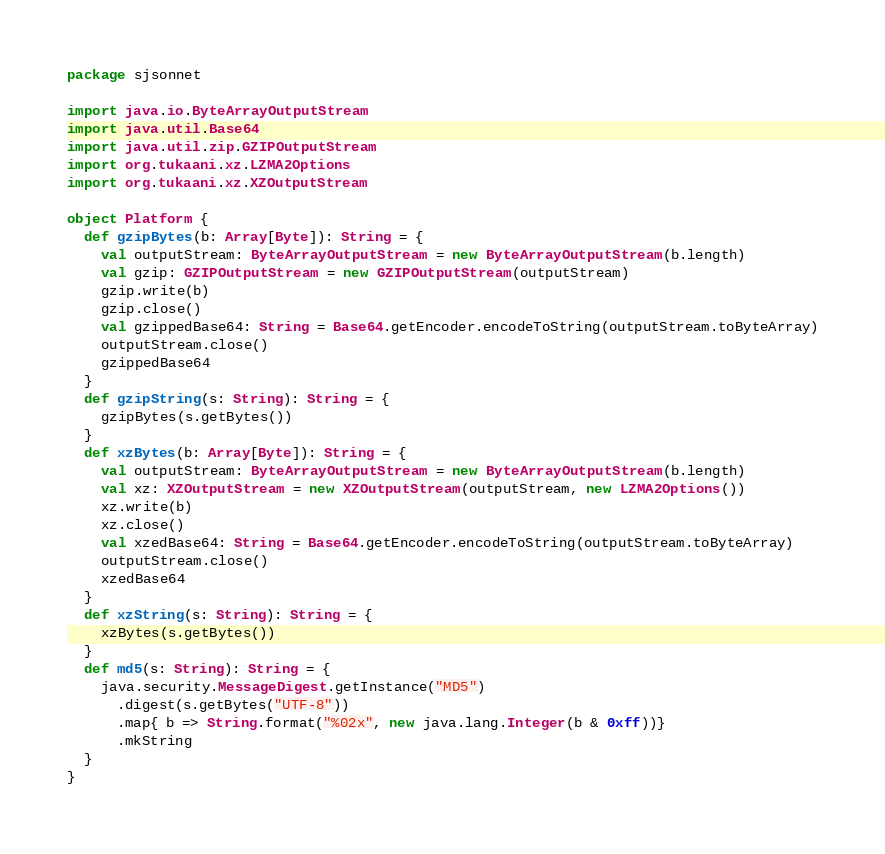Convert code to text. <code><loc_0><loc_0><loc_500><loc_500><_Scala_>package sjsonnet

import java.io.ByteArrayOutputStream
import java.util.Base64
import java.util.zip.GZIPOutputStream
import org.tukaani.xz.LZMA2Options
import org.tukaani.xz.XZOutputStream

object Platform {
  def gzipBytes(b: Array[Byte]): String = {
    val outputStream: ByteArrayOutputStream = new ByteArrayOutputStream(b.length)
    val gzip: GZIPOutputStream = new GZIPOutputStream(outputStream)
    gzip.write(b)
    gzip.close()
    val gzippedBase64: String = Base64.getEncoder.encodeToString(outputStream.toByteArray)
    outputStream.close()
    gzippedBase64
  }
  def gzipString(s: String): String = {
    gzipBytes(s.getBytes())
  }
  def xzBytes(b: Array[Byte]): String = {
    val outputStream: ByteArrayOutputStream = new ByteArrayOutputStream(b.length)
    val xz: XZOutputStream = new XZOutputStream(outputStream, new LZMA2Options())
    xz.write(b)
    xz.close()
    val xzedBase64: String = Base64.getEncoder.encodeToString(outputStream.toByteArray)
    outputStream.close()
    xzedBase64
  }
  def xzString(s: String): String = {
    xzBytes(s.getBytes())
  }
  def md5(s: String): String = {
    java.security.MessageDigest.getInstance("MD5")
      .digest(s.getBytes("UTF-8"))
      .map{ b => String.format("%02x", new java.lang.Integer(b & 0xff))}
      .mkString
  }
}
</code> 